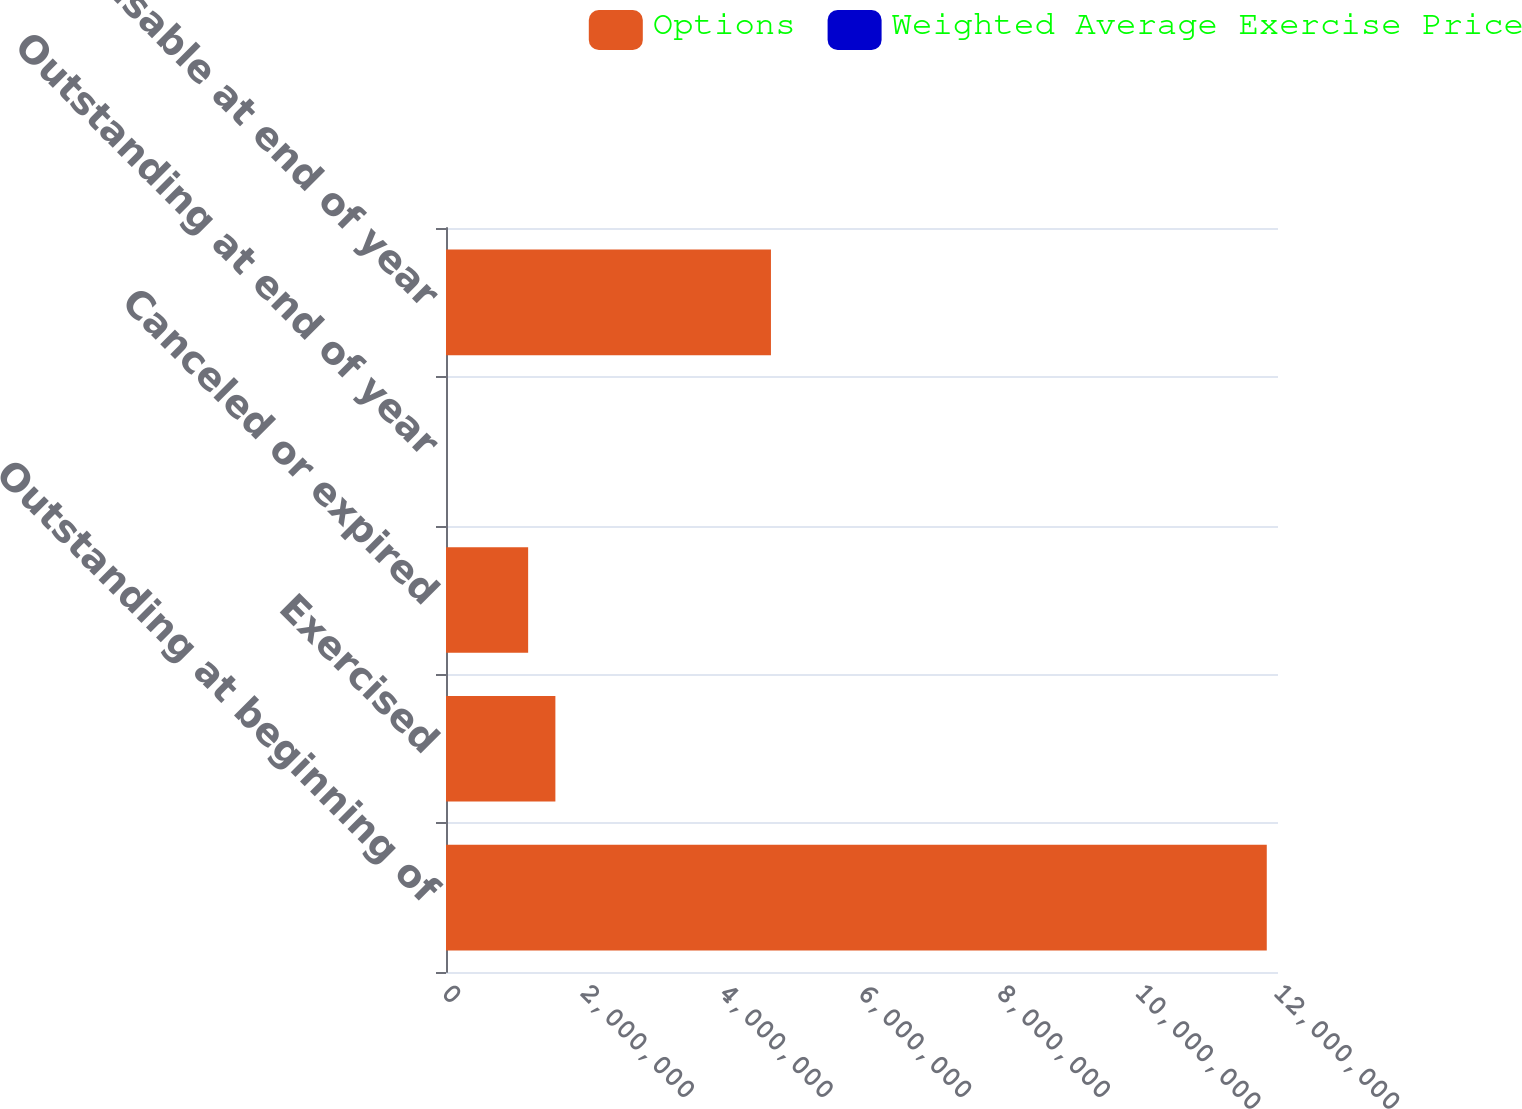<chart> <loc_0><loc_0><loc_500><loc_500><stacked_bar_chart><ecel><fcel>Outstanding at beginning of<fcel>Exercised<fcel>Canceled or expired<fcel>Outstanding at end of year<fcel>Exercisable at end of year<nl><fcel>Options<fcel>1.1838e+07<fcel>1.57764e+06<fcel>1.18474e+06<fcel>18.72<fcel>4.6868e+06<nl><fcel>Weighted Average Exercise Price<fcel>16.07<fcel>6.14<fcel>18.72<fcel>16.19<fcel>14.24<nl></chart> 